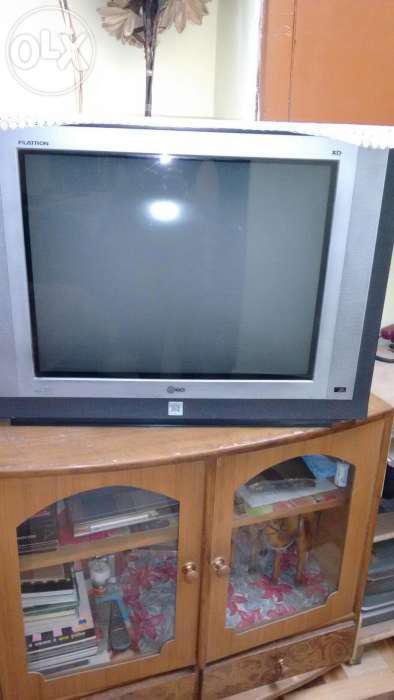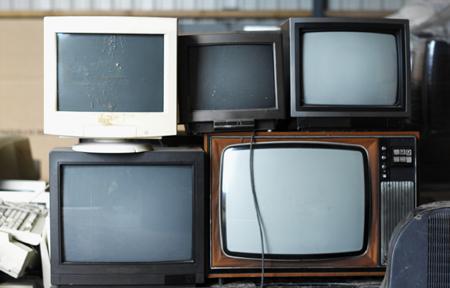The first image is the image on the left, the second image is the image on the right. Given the left and right images, does the statement "An image shows a group of screened appliances stacked on top of one another." hold true? Answer yes or no. Yes. The first image is the image on the left, the second image is the image on the right. Assess this claim about the two images: "There is a single television that is off in the image on the right.". Correct or not? Answer yes or no. No. 